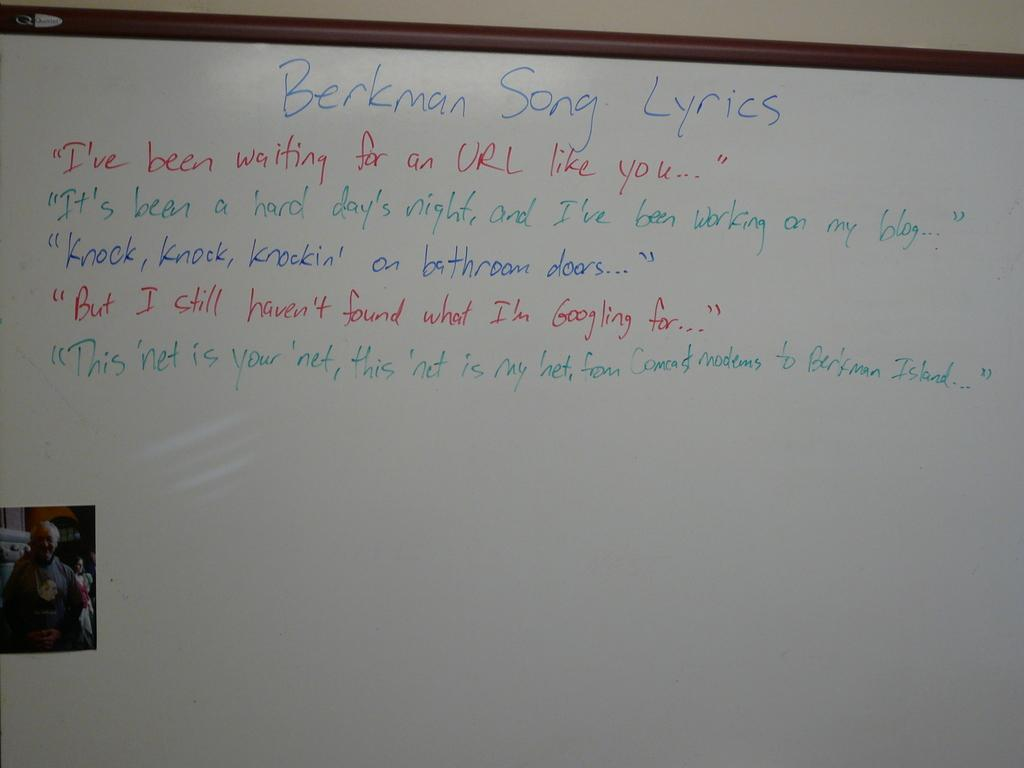<image>
Summarize the visual content of the image. A white board with Berkman song lyrics written on the board. 